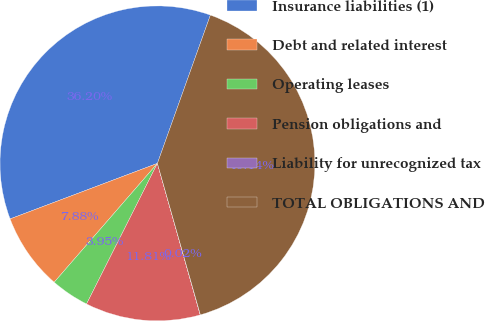Convert chart. <chart><loc_0><loc_0><loc_500><loc_500><pie_chart><fcel>Insurance liabilities (1)<fcel>Debt and related interest<fcel>Operating leases<fcel>Pension obligations and<fcel>Liability for unrecognized tax<fcel>TOTAL OBLIGATIONS AND<nl><fcel>36.2%<fcel>7.88%<fcel>3.95%<fcel>11.81%<fcel>0.02%<fcel>40.14%<nl></chart> 